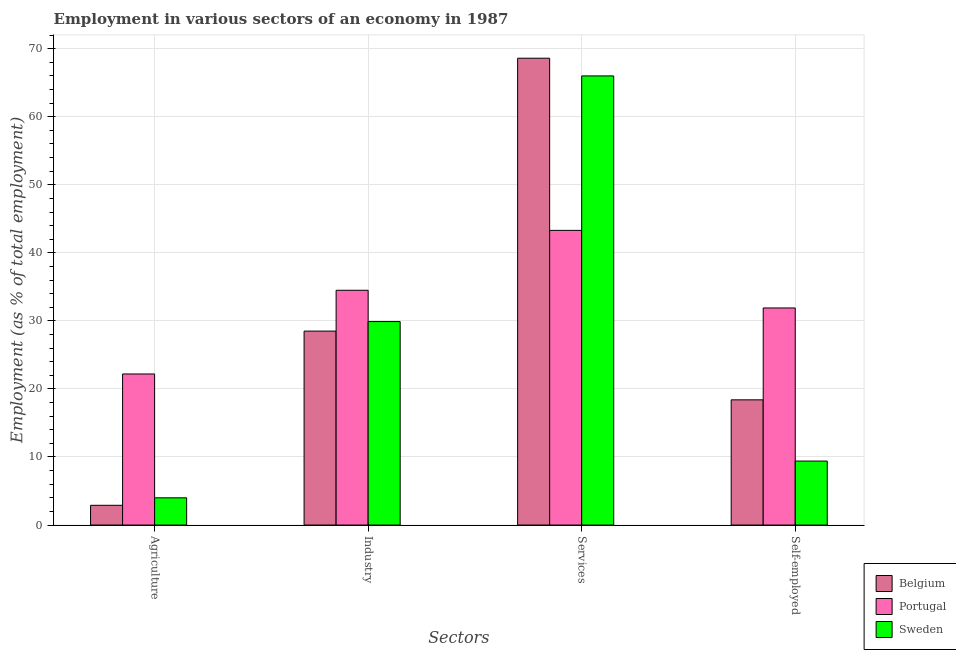How many different coloured bars are there?
Make the answer very short. 3. Are the number of bars per tick equal to the number of legend labels?
Offer a very short reply. Yes. Are the number of bars on each tick of the X-axis equal?
Your answer should be compact. Yes. How many bars are there on the 3rd tick from the left?
Ensure brevity in your answer.  3. What is the label of the 4th group of bars from the left?
Your response must be concise. Self-employed. Across all countries, what is the maximum percentage of self employed workers?
Keep it short and to the point. 31.9. Across all countries, what is the minimum percentage of workers in agriculture?
Make the answer very short. 2.9. In which country was the percentage of workers in services maximum?
Ensure brevity in your answer.  Belgium. What is the total percentage of workers in services in the graph?
Your answer should be compact. 177.9. What is the difference between the percentage of workers in agriculture in Portugal and that in Sweden?
Ensure brevity in your answer.  18.2. What is the difference between the percentage of workers in industry in Sweden and the percentage of workers in services in Portugal?
Your response must be concise. -13.4. What is the average percentage of workers in agriculture per country?
Ensure brevity in your answer.  9.7. What is the difference between the percentage of self employed workers and percentage of workers in industry in Portugal?
Your answer should be compact. -2.6. In how many countries, is the percentage of workers in industry greater than 44 %?
Your response must be concise. 0. What is the ratio of the percentage of workers in agriculture in Sweden to that in Portugal?
Your answer should be very brief. 0.18. Is the difference between the percentage of workers in agriculture in Portugal and Belgium greater than the difference between the percentage of self employed workers in Portugal and Belgium?
Keep it short and to the point. Yes. What is the difference between the highest and the second highest percentage of workers in industry?
Make the answer very short. 4.6. What is the difference between the highest and the lowest percentage of workers in agriculture?
Provide a short and direct response. 19.3. What does the 1st bar from the left in Industry represents?
Offer a terse response. Belgium. What does the 2nd bar from the right in Industry represents?
Offer a terse response. Portugal. How many bars are there?
Provide a short and direct response. 12. How many countries are there in the graph?
Provide a succinct answer. 3. What is the difference between two consecutive major ticks on the Y-axis?
Keep it short and to the point. 10. Are the values on the major ticks of Y-axis written in scientific E-notation?
Your answer should be compact. No. Does the graph contain any zero values?
Make the answer very short. No. Where does the legend appear in the graph?
Keep it short and to the point. Bottom right. How many legend labels are there?
Provide a succinct answer. 3. How are the legend labels stacked?
Offer a very short reply. Vertical. What is the title of the graph?
Provide a succinct answer. Employment in various sectors of an economy in 1987. Does "Caribbean small states" appear as one of the legend labels in the graph?
Your response must be concise. No. What is the label or title of the X-axis?
Your answer should be very brief. Sectors. What is the label or title of the Y-axis?
Ensure brevity in your answer.  Employment (as % of total employment). What is the Employment (as % of total employment) in Belgium in Agriculture?
Ensure brevity in your answer.  2.9. What is the Employment (as % of total employment) in Portugal in Agriculture?
Offer a very short reply. 22.2. What is the Employment (as % of total employment) in Portugal in Industry?
Your response must be concise. 34.5. What is the Employment (as % of total employment) in Sweden in Industry?
Ensure brevity in your answer.  29.9. What is the Employment (as % of total employment) in Belgium in Services?
Your response must be concise. 68.6. What is the Employment (as % of total employment) of Portugal in Services?
Your answer should be compact. 43.3. What is the Employment (as % of total employment) in Sweden in Services?
Your response must be concise. 66. What is the Employment (as % of total employment) in Belgium in Self-employed?
Your answer should be very brief. 18.4. What is the Employment (as % of total employment) in Portugal in Self-employed?
Your answer should be very brief. 31.9. What is the Employment (as % of total employment) of Sweden in Self-employed?
Give a very brief answer. 9.4. Across all Sectors, what is the maximum Employment (as % of total employment) in Belgium?
Your answer should be very brief. 68.6. Across all Sectors, what is the maximum Employment (as % of total employment) in Portugal?
Offer a terse response. 43.3. Across all Sectors, what is the minimum Employment (as % of total employment) of Belgium?
Your answer should be compact. 2.9. Across all Sectors, what is the minimum Employment (as % of total employment) of Portugal?
Ensure brevity in your answer.  22.2. What is the total Employment (as % of total employment) of Belgium in the graph?
Provide a short and direct response. 118.4. What is the total Employment (as % of total employment) of Portugal in the graph?
Your answer should be very brief. 131.9. What is the total Employment (as % of total employment) in Sweden in the graph?
Make the answer very short. 109.3. What is the difference between the Employment (as % of total employment) of Belgium in Agriculture and that in Industry?
Your response must be concise. -25.6. What is the difference between the Employment (as % of total employment) of Sweden in Agriculture and that in Industry?
Your answer should be compact. -25.9. What is the difference between the Employment (as % of total employment) in Belgium in Agriculture and that in Services?
Give a very brief answer. -65.7. What is the difference between the Employment (as % of total employment) of Portugal in Agriculture and that in Services?
Offer a terse response. -21.1. What is the difference between the Employment (as % of total employment) in Sweden in Agriculture and that in Services?
Make the answer very short. -62. What is the difference between the Employment (as % of total employment) of Belgium in Agriculture and that in Self-employed?
Your response must be concise. -15.5. What is the difference between the Employment (as % of total employment) of Portugal in Agriculture and that in Self-employed?
Provide a short and direct response. -9.7. What is the difference between the Employment (as % of total employment) in Sweden in Agriculture and that in Self-employed?
Your response must be concise. -5.4. What is the difference between the Employment (as % of total employment) of Belgium in Industry and that in Services?
Ensure brevity in your answer.  -40.1. What is the difference between the Employment (as % of total employment) in Portugal in Industry and that in Services?
Make the answer very short. -8.8. What is the difference between the Employment (as % of total employment) of Sweden in Industry and that in Services?
Offer a very short reply. -36.1. What is the difference between the Employment (as % of total employment) in Belgium in Industry and that in Self-employed?
Your answer should be compact. 10.1. What is the difference between the Employment (as % of total employment) in Portugal in Industry and that in Self-employed?
Offer a terse response. 2.6. What is the difference between the Employment (as % of total employment) in Sweden in Industry and that in Self-employed?
Your answer should be compact. 20.5. What is the difference between the Employment (as % of total employment) in Belgium in Services and that in Self-employed?
Your answer should be very brief. 50.2. What is the difference between the Employment (as % of total employment) of Portugal in Services and that in Self-employed?
Provide a succinct answer. 11.4. What is the difference between the Employment (as % of total employment) of Sweden in Services and that in Self-employed?
Provide a short and direct response. 56.6. What is the difference between the Employment (as % of total employment) in Belgium in Agriculture and the Employment (as % of total employment) in Portugal in Industry?
Provide a succinct answer. -31.6. What is the difference between the Employment (as % of total employment) of Belgium in Agriculture and the Employment (as % of total employment) of Sweden in Industry?
Your answer should be compact. -27. What is the difference between the Employment (as % of total employment) of Portugal in Agriculture and the Employment (as % of total employment) of Sweden in Industry?
Make the answer very short. -7.7. What is the difference between the Employment (as % of total employment) of Belgium in Agriculture and the Employment (as % of total employment) of Portugal in Services?
Give a very brief answer. -40.4. What is the difference between the Employment (as % of total employment) in Belgium in Agriculture and the Employment (as % of total employment) in Sweden in Services?
Offer a terse response. -63.1. What is the difference between the Employment (as % of total employment) of Portugal in Agriculture and the Employment (as % of total employment) of Sweden in Services?
Your answer should be very brief. -43.8. What is the difference between the Employment (as % of total employment) of Belgium in Agriculture and the Employment (as % of total employment) of Portugal in Self-employed?
Offer a terse response. -29. What is the difference between the Employment (as % of total employment) of Portugal in Agriculture and the Employment (as % of total employment) of Sweden in Self-employed?
Offer a terse response. 12.8. What is the difference between the Employment (as % of total employment) in Belgium in Industry and the Employment (as % of total employment) in Portugal in Services?
Your answer should be compact. -14.8. What is the difference between the Employment (as % of total employment) of Belgium in Industry and the Employment (as % of total employment) of Sweden in Services?
Give a very brief answer. -37.5. What is the difference between the Employment (as % of total employment) of Portugal in Industry and the Employment (as % of total employment) of Sweden in Services?
Provide a succinct answer. -31.5. What is the difference between the Employment (as % of total employment) in Belgium in Industry and the Employment (as % of total employment) in Portugal in Self-employed?
Your response must be concise. -3.4. What is the difference between the Employment (as % of total employment) in Belgium in Industry and the Employment (as % of total employment) in Sweden in Self-employed?
Keep it short and to the point. 19.1. What is the difference between the Employment (as % of total employment) in Portugal in Industry and the Employment (as % of total employment) in Sweden in Self-employed?
Your answer should be very brief. 25.1. What is the difference between the Employment (as % of total employment) in Belgium in Services and the Employment (as % of total employment) in Portugal in Self-employed?
Provide a short and direct response. 36.7. What is the difference between the Employment (as % of total employment) of Belgium in Services and the Employment (as % of total employment) of Sweden in Self-employed?
Your answer should be compact. 59.2. What is the difference between the Employment (as % of total employment) of Portugal in Services and the Employment (as % of total employment) of Sweden in Self-employed?
Your response must be concise. 33.9. What is the average Employment (as % of total employment) of Belgium per Sectors?
Your response must be concise. 29.6. What is the average Employment (as % of total employment) of Portugal per Sectors?
Your response must be concise. 32.98. What is the average Employment (as % of total employment) of Sweden per Sectors?
Provide a succinct answer. 27.32. What is the difference between the Employment (as % of total employment) in Belgium and Employment (as % of total employment) in Portugal in Agriculture?
Your answer should be very brief. -19.3. What is the difference between the Employment (as % of total employment) of Belgium and Employment (as % of total employment) of Portugal in Industry?
Your answer should be very brief. -6. What is the difference between the Employment (as % of total employment) of Belgium and Employment (as % of total employment) of Portugal in Services?
Make the answer very short. 25.3. What is the difference between the Employment (as % of total employment) of Portugal and Employment (as % of total employment) of Sweden in Services?
Your response must be concise. -22.7. What is the difference between the Employment (as % of total employment) of Portugal and Employment (as % of total employment) of Sweden in Self-employed?
Offer a very short reply. 22.5. What is the ratio of the Employment (as % of total employment) of Belgium in Agriculture to that in Industry?
Ensure brevity in your answer.  0.1. What is the ratio of the Employment (as % of total employment) in Portugal in Agriculture to that in Industry?
Keep it short and to the point. 0.64. What is the ratio of the Employment (as % of total employment) of Sweden in Agriculture to that in Industry?
Your answer should be compact. 0.13. What is the ratio of the Employment (as % of total employment) in Belgium in Agriculture to that in Services?
Your answer should be very brief. 0.04. What is the ratio of the Employment (as % of total employment) of Portugal in Agriculture to that in Services?
Provide a succinct answer. 0.51. What is the ratio of the Employment (as % of total employment) of Sweden in Agriculture to that in Services?
Ensure brevity in your answer.  0.06. What is the ratio of the Employment (as % of total employment) in Belgium in Agriculture to that in Self-employed?
Offer a very short reply. 0.16. What is the ratio of the Employment (as % of total employment) in Portugal in Agriculture to that in Self-employed?
Provide a short and direct response. 0.7. What is the ratio of the Employment (as % of total employment) in Sweden in Agriculture to that in Self-employed?
Your answer should be compact. 0.43. What is the ratio of the Employment (as % of total employment) of Belgium in Industry to that in Services?
Your response must be concise. 0.42. What is the ratio of the Employment (as % of total employment) in Portugal in Industry to that in Services?
Offer a very short reply. 0.8. What is the ratio of the Employment (as % of total employment) of Sweden in Industry to that in Services?
Your response must be concise. 0.45. What is the ratio of the Employment (as % of total employment) of Belgium in Industry to that in Self-employed?
Offer a very short reply. 1.55. What is the ratio of the Employment (as % of total employment) of Portugal in Industry to that in Self-employed?
Offer a very short reply. 1.08. What is the ratio of the Employment (as % of total employment) in Sweden in Industry to that in Self-employed?
Your response must be concise. 3.18. What is the ratio of the Employment (as % of total employment) in Belgium in Services to that in Self-employed?
Your answer should be very brief. 3.73. What is the ratio of the Employment (as % of total employment) in Portugal in Services to that in Self-employed?
Provide a succinct answer. 1.36. What is the ratio of the Employment (as % of total employment) in Sweden in Services to that in Self-employed?
Your answer should be very brief. 7.02. What is the difference between the highest and the second highest Employment (as % of total employment) in Belgium?
Your answer should be very brief. 40.1. What is the difference between the highest and the second highest Employment (as % of total employment) of Sweden?
Your answer should be very brief. 36.1. What is the difference between the highest and the lowest Employment (as % of total employment) of Belgium?
Your response must be concise. 65.7. What is the difference between the highest and the lowest Employment (as % of total employment) in Portugal?
Keep it short and to the point. 21.1. What is the difference between the highest and the lowest Employment (as % of total employment) in Sweden?
Your response must be concise. 62. 